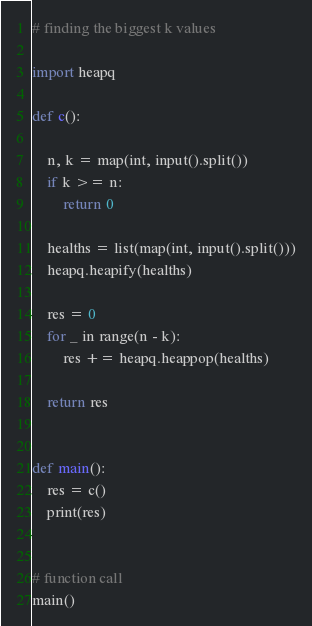<code> <loc_0><loc_0><loc_500><loc_500><_Python_># finding the biggest k values

import heapq

def c():
    
    n, k = map(int, input().split())
    if k >= n:
        return 0

    healths = list(map(int, input().split()))
    heapq.heapify(healths)

    res = 0
    for _ in range(n - k):
        res += heapq.heappop(healths)

    return res


def main():
    res = c()
    print(res)

    
# function call 
main()
</code> 